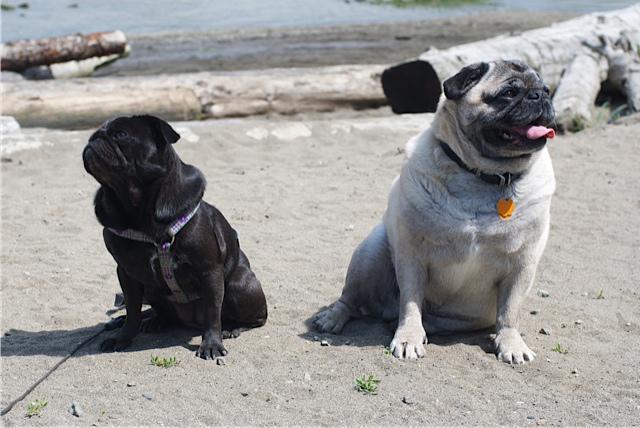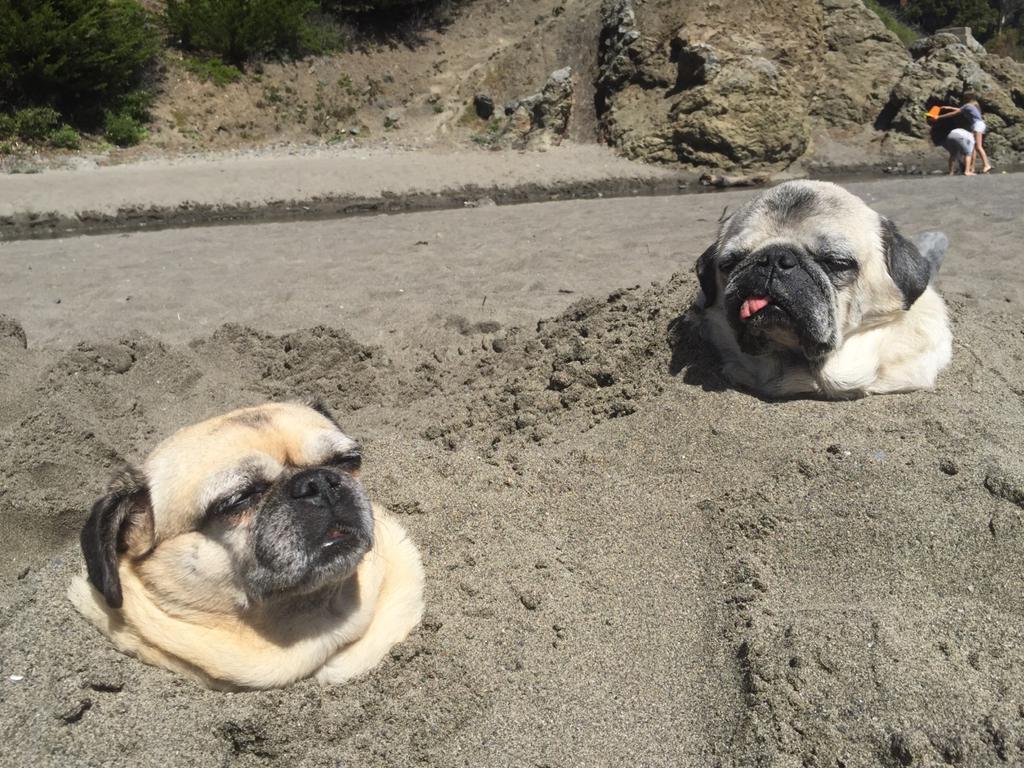The first image is the image on the left, the second image is the image on the right. Given the left and right images, does the statement "An animal wearing clothing is present." hold true? Answer yes or no. No. The first image is the image on the left, the second image is the image on the right. Given the left and right images, does the statement "Four dogs are in sand." hold true? Answer yes or no. Yes. 